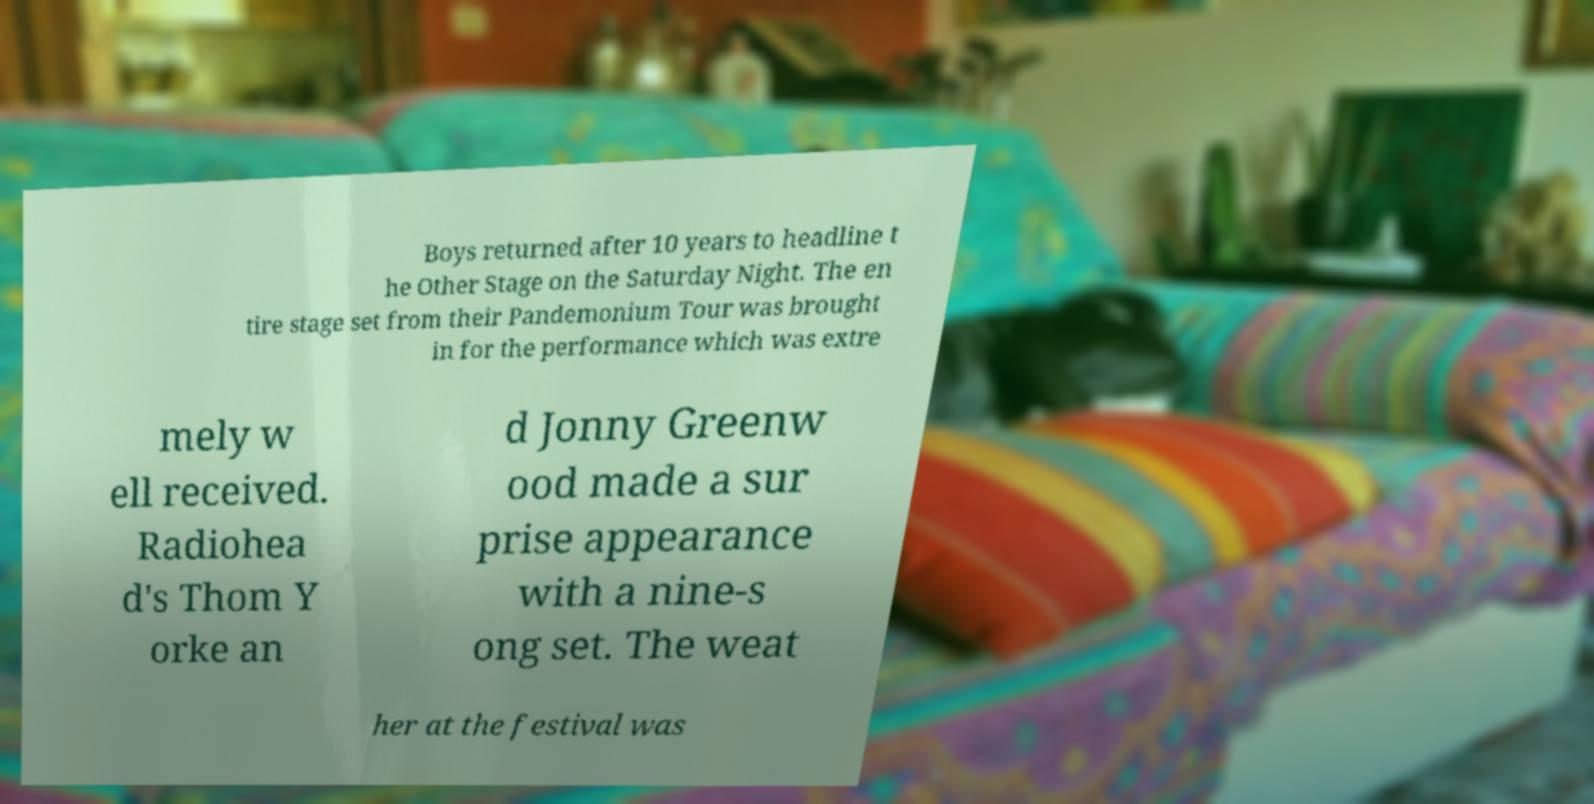What messages or text are displayed in this image? I need them in a readable, typed format. Boys returned after 10 years to headline t he Other Stage on the Saturday Night. The en tire stage set from their Pandemonium Tour was brought in for the performance which was extre mely w ell received. Radiohea d's Thom Y orke an d Jonny Greenw ood made a sur prise appearance with a nine-s ong set. The weat her at the festival was 